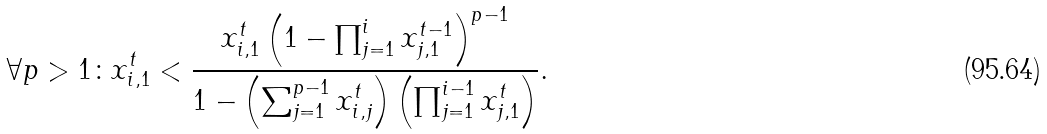<formula> <loc_0><loc_0><loc_500><loc_500>\forall p > 1 \colon x _ { i , 1 } ^ { t } < \frac { x _ { i , 1 } ^ { t } \left ( 1 - \prod _ { j = 1 } ^ { i } x _ { j , 1 } ^ { t - 1 } \right ) ^ { p - 1 } } { 1 - \left ( \sum _ { j = 1 } ^ { p - 1 } x _ { i , j } ^ { t } \right ) \left ( \prod _ { j = 1 } ^ { i - 1 } x _ { j , 1 } ^ { t } \right ) } .</formula> 